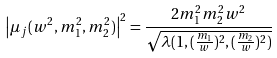<formula> <loc_0><loc_0><loc_500><loc_500>\left | \mu _ { j } ( w ^ { 2 } , m _ { 1 } ^ { 2 } , m _ { 2 } ^ { 2 } ) \right | ^ { 2 } = \frac { 2 m _ { 1 } ^ { 2 } m _ { 2 } ^ { 2 } w ^ { 2 } } { \sqrt { \lambda ( 1 , ( \frac { m _ { 1 } } { w } ) ^ { 2 } , ( \frac { m _ { 2 } } { w } ) ^ { 2 } ) } }</formula> 